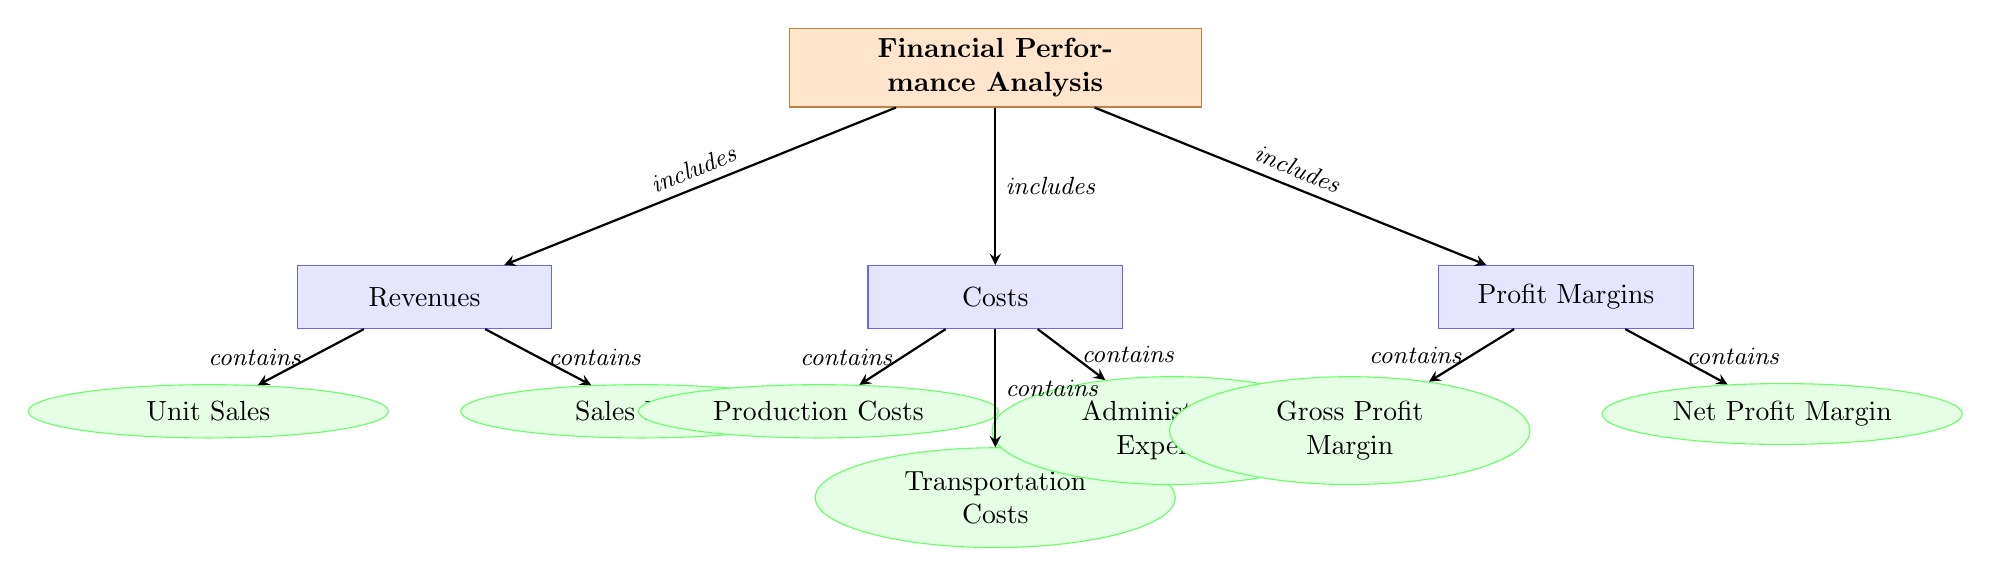What are the three main categories included in the financial performance analysis? The diagram lists three main categories: Revenues, Costs, and Profit Margins, which are directly under the main node labeled "Financial Performance Analysis."
Answer: Revenues, Costs, Profit Margins How many subcategories are shown under the Revenues category? The Revenues category includes two subcategories: Unit Sales and Sales Price, which can be seen branching off from the Revenues node.
Answer: 2 Which type of expenses fall under the Costs category? The Costs category contains three subcategories indicated as: Production Costs, Transportation Costs, and Administrative Expenses, showing the different types of costs tracked in the financial analysis.
Answer: Production Costs, Transportation Costs, Administrative Expenses What type of profit margin is represented by the subcategory under Profits? The Profits category contains two types of profit margins: Gross Profit Margin and Net Profit Margin, as represented by the subcategories under the Profits main category.
Answer: Gross Profit Margin, Net Profit Margin What is the relationship between the Revenues category and its subcategories? The Revenues category contains Unit Sales and Sales Price, which means it includes these subcategories. The arrows indicate that these elements are integral parts of the Revenues category.
Answer: contains Which categories are included in the Financial Performance Analysis? The diagram indicates that the Financial Performance Analysis includes Revenues, Costs, and Profit Margins, directly showing the three major components.
Answer: Revenues, Costs, Profit Margins What is the main purpose of the diagram? The diagram aims to provide a structured overview of the financial performance analysis for the iron ore division, detailing how revenues, costs, and profit margins are interconnected.
Answer: Financial performance analysis How are the subcategories organized under each main category? The subcategories are organized hierarchically under their respective main categories, with an arrow indicating the 'contains' relationship that links them to their categories, demonstrating the structure.
Answer: Hierarchical organization with 'contains' relationship 